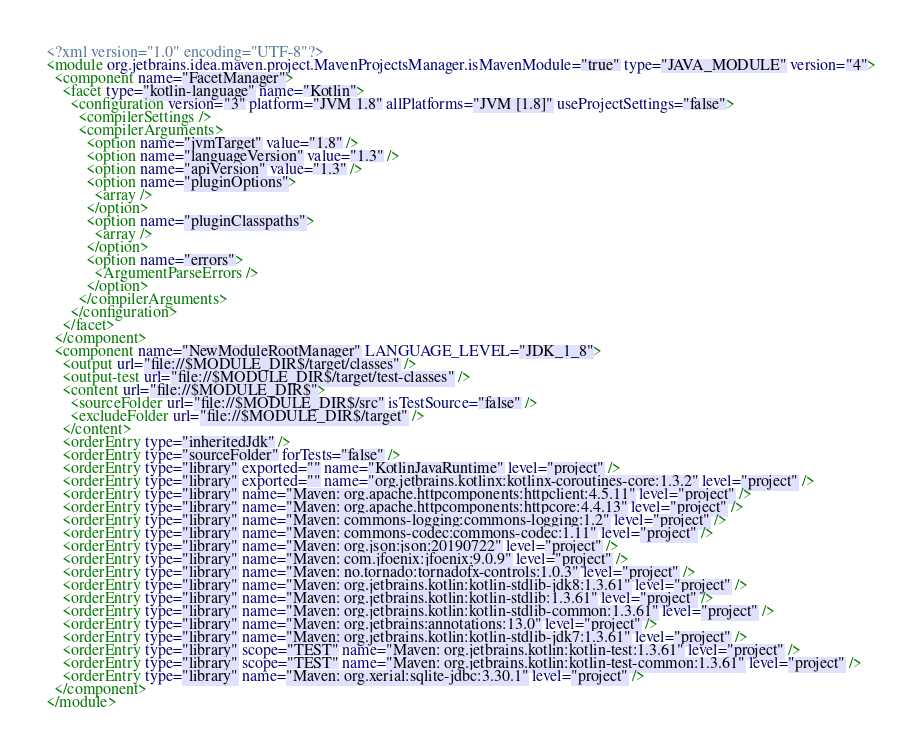<code> <loc_0><loc_0><loc_500><loc_500><_XML_><?xml version="1.0" encoding="UTF-8"?>
<module org.jetbrains.idea.maven.project.MavenProjectsManager.isMavenModule="true" type="JAVA_MODULE" version="4">
  <component name="FacetManager">
    <facet type="kotlin-language" name="Kotlin">
      <configuration version="3" platform="JVM 1.8" allPlatforms="JVM [1.8]" useProjectSettings="false">
        <compilerSettings />
        <compilerArguments>
          <option name="jvmTarget" value="1.8" />
          <option name="languageVersion" value="1.3" />
          <option name="apiVersion" value="1.3" />
          <option name="pluginOptions">
            <array />
          </option>
          <option name="pluginClasspaths">
            <array />
          </option>
          <option name="errors">
            <ArgumentParseErrors />
          </option>
        </compilerArguments>
      </configuration>
    </facet>
  </component>
  <component name="NewModuleRootManager" LANGUAGE_LEVEL="JDK_1_8">
    <output url="file://$MODULE_DIR$/target/classes" />
    <output-test url="file://$MODULE_DIR$/target/test-classes" />
    <content url="file://$MODULE_DIR$">
      <sourceFolder url="file://$MODULE_DIR$/src" isTestSource="false" />
      <excludeFolder url="file://$MODULE_DIR$/target" />
    </content>
    <orderEntry type="inheritedJdk" />
    <orderEntry type="sourceFolder" forTests="false" />
    <orderEntry type="library" exported="" name="KotlinJavaRuntime" level="project" />
    <orderEntry type="library" exported="" name="org.jetbrains.kotlinx:kotlinx-coroutines-core:1.3.2" level="project" />
    <orderEntry type="library" name="Maven: org.apache.httpcomponents:httpclient:4.5.11" level="project" />
    <orderEntry type="library" name="Maven: org.apache.httpcomponents:httpcore:4.4.13" level="project" />
    <orderEntry type="library" name="Maven: commons-logging:commons-logging:1.2" level="project" />
    <orderEntry type="library" name="Maven: commons-codec:commons-codec:1.11" level="project" />
    <orderEntry type="library" name="Maven: org.json:json:20190722" level="project" />
    <orderEntry type="library" name="Maven: com.jfoenix:jfoenix:9.0.9" level="project" />
    <orderEntry type="library" name="Maven: no.tornado:tornadofx-controls:1.0.3" level="project" />
    <orderEntry type="library" name="Maven: org.jetbrains.kotlin:kotlin-stdlib-jdk8:1.3.61" level="project" />
    <orderEntry type="library" name="Maven: org.jetbrains.kotlin:kotlin-stdlib:1.3.61" level="project" />
    <orderEntry type="library" name="Maven: org.jetbrains.kotlin:kotlin-stdlib-common:1.3.61" level="project" />
    <orderEntry type="library" name="Maven: org.jetbrains:annotations:13.0" level="project" />
    <orderEntry type="library" name="Maven: org.jetbrains.kotlin:kotlin-stdlib-jdk7:1.3.61" level="project" />
    <orderEntry type="library" scope="TEST" name="Maven: org.jetbrains.kotlin:kotlin-test:1.3.61" level="project" />
    <orderEntry type="library" scope="TEST" name="Maven: org.jetbrains.kotlin:kotlin-test-common:1.3.61" level="project" />
    <orderEntry type="library" name="Maven: org.xerial:sqlite-jdbc:3.30.1" level="project" />
  </component>
</module></code> 